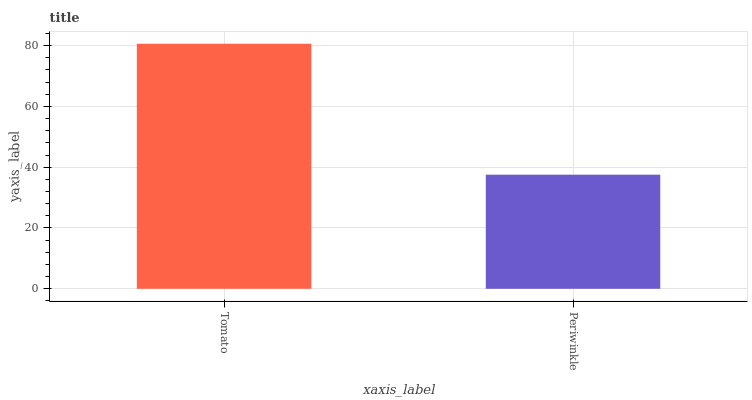Is Periwinkle the minimum?
Answer yes or no. Yes. Is Tomato the maximum?
Answer yes or no. Yes. Is Periwinkle the maximum?
Answer yes or no. No. Is Tomato greater than Periwinkle?
Answer yes or no. Yes. Is Periwinkle less than Tomato?
Answer yes or no. Yes. Is Periwinkle greater than Tomato?
Answer yes or no. No. Is Tomato less than Periwinkle?
Answer yes or no. No. Is Tomato the high median?
Answer yes or no. Yes. Is Periwinkle the low median?
Answer yes or no. Yes. Is Periwinkle the high median?
Answer yes or no. No. Is Tomato the low median?
Answer yes or no. No. 